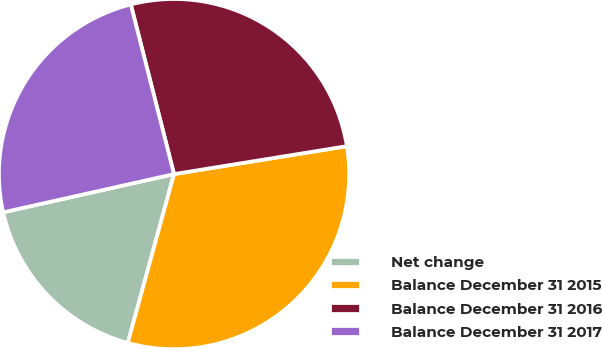Convert chart. <chart><loc_0><loc_0><loc_500><loc_500><pie_chart><fcel>Net change<fcel>Balance December 31 2015<fcel>Balance December 31 2016<fcel>Balance December 31 2017<nl><fcel>17.24%<fcel>31.8%<fcel>26.42%<fcel>24.53%<nl></chart> 